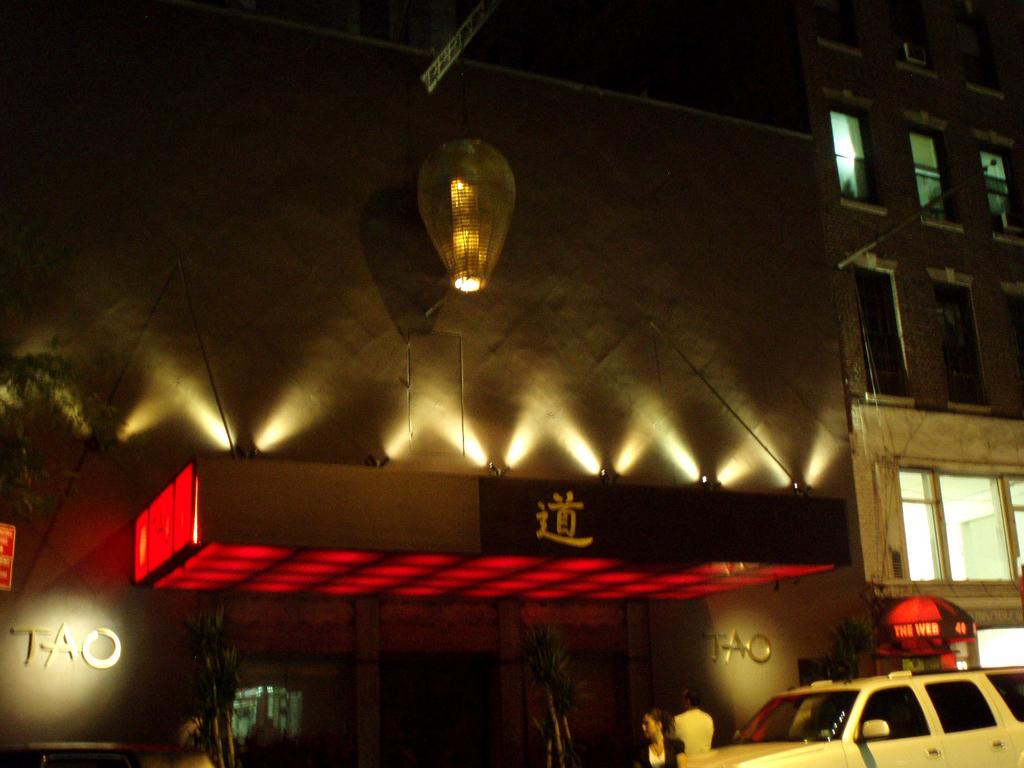What city is on the sign?
Your answer should be compact. Tao. 